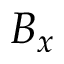Convert formula to latex. <formula><loc_0><loc_0><loc_500><loc_500>B _ { x }</formula> 